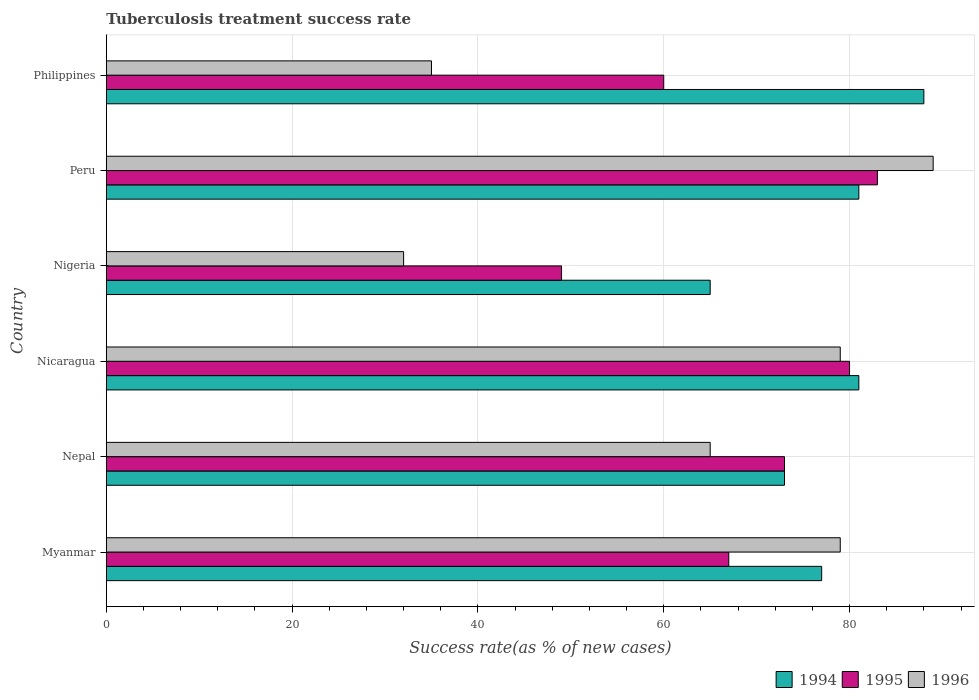Are the number of bars per tick equal to the number of legend labels?
Your answer should be very brief. Yes. How many bars are there on the 3rd tick from the top?
Your response must be concise. 3. How many bars are there on the 3rd tick from the bottom?
Give a very brief answer. 3. What is the label of the 1st group of bars from the top?
Your response must be concise. Philippines. In how many cases, is the number of bars for a given country not equal to the number of legend labels?
Make the answer very short. 0. What is the tuberculosis treatment success rate in 1995 in Philippines?
Provide a short and direct response. 60. Across all countries, what is the minimum tuberculosis treatment success rate in 1994?
Offer a very short reply. 65. In which country was the tuberculosis treatment success rate in 1996 maximum?
Offer a very short reply. Peru. In which country was the tuberculosis treatment success rate in 1995 minimum?
Provide a short and direct response. Nigeria. What is the total tuberculosis treatment success rate in 1994 in the graph?
Your answer should be compact. 465. What is the difference between the tuberculosis treatment success rate in 1994 in Myanmar and the tuberculosis treatment success rate in 1995 in Nigeria?
Your response must be concise. 28. What is the average tuberculosis treatment success rate in 1995 per country?
Provide a short and direct response. 68.67. What is the difference between the tuberculosis treatment success rate in 1996 and tuberculosis treatment success rate in 1995 in Peru?
Provide a succinct answer. 6. What is the ratio of the tuberculosis treatment success rate in 1995 in Myanmar to that in Philippines?
Ensure brevity in your answer.  1.12. In how many countries, is the tuberculosis treatment success rate in 1996 greater than the average tuberculosis treatment success rate in 1996 taken over all countries?
Ensure brevity in your answer.  4. What does the 3rd bar from the top in Nepal represents?
Provide a short and direct response. 1994. How many bars are there?
Provide a succinct answer. 18. Are all the bars in the graph horizontal?
Your answer should be compact. Yes. Does the graph contain any zero values?
Your response must be concise. No. How many legend labels are there?
Provide a short and direct response. 3. How are the legend labels stacked?
Your answer should be very brief. Horizontal. What is the title of the graph?
Your answer should be very brief. Tuberculosis treatment success rate. What is the label or title of the X-axis?
Your answer should be compact. Success rate(as % of new cases). What is the label or title of the Y-axis?
Ensure brevity in your answer.  Country. What is the Success rate(as % of new cases) of 1996 in Myanmar?
Make the answer very short. 79. What is the Success rate(as % of new cases) in 1995 in Nepal?
Give a very brief answer. 73. What is the Success rate(as % of new cases) in 1995 in Nicaragua?
Keep it short and to the point. 80. What is the Success rate(as % of new cases) of 1996 in Nicaragua?
Provide a succinct answer. 79. What is the Success rate(as % of new cases) of 1994 in Nigeria?
Ensure brevity in your answer.  65. What is the Success rate(as % of new cases) in 1995 in Nigeria?
Ensure brevity in your answer.  49. What is the Success rate(as % of new cases) in 1996 in Nigeria?
Provide a short and direct response. 32. What is the Success rate(as % of new cases) of 1995 in Peru?
Give a very brief answer. 83. What is the Success rate(as % of new cases) in 1996 in Peru?
Provide a succinct answer. 89. What is the Success rate(as % of new cases) of 1994 in Philippines?
Keep it short and to the point. 88. What is the Success rate(as % of new cases) of 1996 in Philippines?
Your answer should be compact. 35. Across all countries, what is the maximum Success rate(as % of new cases) of 1996?
Provide a succinct answer. 89. What is the total Success rate(as % of new cases) of 1994 in the graph?
Give a very brief answer. 465. What is the total Success rate(as % of new cases) in 1995 in the graph?
Offer a very short reply. 412. What is the total Success rate(as % of new cases) in 1996 in the graph?
Give a very brief answer. 379. What is the difference between the Success rate(as % of new cases) of 1994 in Myanmar and that in Nepal?
Your answer should be very brief. 4. What is the difference between the Success rate(as % of new cases) of 1996 in Myanmar and that in Nigeria?
Your answer should be very brief. 47. What is the difference between the Success rate(as % of new cases) of 1996 in Myanmar and that in Peru?
Offer a very short reply. -10. What is the difference between the Success rate(as % of new cases) of 1994 in Myanmar and that in Philippines?
Ensure brevity in your answer.  -11. What is the difference between the Success rate(as % of new cases) in 1995 in Myanmar and that in Philippines?
Offer a very short reply. 7. What is the difference between the Success rate(as % of new cases) in 1996 in Myanmar and that in Philippines?
Keep it short and to the point. 44. What is the difference between the Success rate(as % of new cases) of 1995 in Nepal and that in Nigeria?
Keep it short and to the point. 24. What is the difference between the Success rate(as % of new cases) in 1996 in Nepal and that in Peru?
Your answer should be very brief. -24. What is the difference between the Success rate(as % of new cases) in 1995 in Nepal and that in Philippines?
Offer a very short reply. 13. What is the difference between the Success rate(as % of new cases) of 1996 in Nepal and that in Philippines?
Your response must be concise. 30. What is the difference between the Success rate(as % of new cases) of 1995 in Nicaragua and that in Peru?
Offer a terse response. -3. What is the difference between the Success rate(as % of new cases) of 1994 in Nicaragua and that in Philippines?
Offer a terse response. -7. What is the difference between the Success rate(as % of new cases) in 1995 in Nicaragua and that in Philippines?
Provide a succinct answer. 20. What is the difference between the Success rate(as % of new cases) of 1996 in Nicaragua and that in Philippines?
Offer a very short reply. 44. What is the difference between the Success rate(as % of new cases) of 1994 in Nigeria and that in Peru?
Your answer should be compact. -16. What is the difference between the Success rate(as % of new cases) of 1995 in Nigeria and that in Peru?
Ensure brevity in your answer.  -34. What is the difference between the Success rate(as % of new cases) of 1996 in Nigeria and that in Peru?
Your response must be concise. -57. What is the difference between the Success rate(as % of new cases) of 1994 in Nigeria and that in Philippines?
Keep it short and to the point. -23. What is the difference between the Success rate(as % of new cases) in 1995 in Nigeria and that in Philippines?
Provide a succinct answer. -11. What is the difference between the Success rate(as % of new cases) in 1996 in Nigeria and that in Philippines?
Offer a terse response. -3. What is the difference between the Success rate(as % of new cases) of 1995 in Myanmar and the Success rate(as % of new cases) of 1996 in Nepal?
Keep it short and to the point. 2. What is the difference between the Success rate(as % of new cases) of 1995 in Myanmar and the Success rate(as % of new cases) of 1996 in Nicaragua?
Offer a terse response. -12. What is the difference between the Success rate(as % of new cases) of 1995 in Myanmar and the Success rate(as % of new cases) of 1996 in Nigeria?
Give a very brief answer. 35. What is the difference between the Success rate(as % of new cases) of 1994 in Myanmar and the Success rate(as % of new cases) of 1995 in Peru?
Provide a succinct answer. -6. What is the difference between the Success rate(as % of new cases) of 1994 in Myanmar and the Success rate(as % of new cases) of 1996 in Peru?
Provide a short and direct response. -12. What is the difference between the Success rate(as % of new cases) of 1994 in Myanmar and the Success rate(as % of new cases) of 1996 in Philippines?
Provide a short and direct response. 42. What is the difference between the Success rate(as % of new cases) in 1995 in Myanmar and the Success rate(as % of new cases) in 1996 in Philippines?
Your answer should be very brief. 32. What is the difference between the Success rate(as % of new cases) of 1994 in Nepal and the Success rate(as % of new cases) of 1996 in Nicaragua?
Provide a short and direct response. -6. What is the difference between the Success rate(as % of new cases) in 1994 in Nepal and the Success rate(as % of new cases) in 1995 in Nigeria?
Ensure brevity in your answer.  24. What is the difference between the Success rate(as % of new cases) in 1994 in Nepal and the Success rate(as % of new cases) in 1995 in Peru?
Keep it short and to the point. -10. What is the difference between the Success rate(as % of new cases) in 1994 in Nepal and the Success rate(as % of new cases) in 1995 in Philippines?
Offer a very short reply. 13. What is the difference between the Success rate(as % of new cases) in 1994 in Nicaragua and the Success rate(as % of new cases) in 1995 in Peru?
Your answer should be very brief. -2. What is the difference between the Success rate(as % of new cases) of 1995 in Nicaragua and the Success rate(as % of new cases) of 1996 in Peru?
Offer a terse response. -9. What is the difference between the Success rate(as % of new cases) in 1995 in Nicaragua and the Success rate(as % of new cases) in 1996 in Philippines?
Your answer should be compact. 45. What is the difference between the Success rate(as % of new cases) in 1995 in Nigeria and the Success rate(as % of new cases) in 1996 in Peru?
Make the answer very short. -40. What is the difference between the Success rate(as % of new cases) of 1994 in Nigeria and the Success rate(as % of new cases) of 1995 in Philippines?
Offer a very short reply. 5. What is the difference between the Success rate(as % of new cases) of 1994 in Nigeria and the Success rate(as % of new cases) of 1996 in Philippines?
Make the answer very short. 30. What is the difference between the Success rate(as % of new cases) in 1994 in Peru and the Success rate(as % of new cases) in 1996 in Philippines?
Give a very brief answer. 46. What is the difference between the Success rate(as % of new cases) of 1995 in Peru and the Success rate(as % of new cases) of 1996 in Philippines?
Provide a short and direct response. 48. What is the average Success rate(as % of new cases) of 1994 per country?
Give a very brief answer. 77.5. What is the average Success rate(as % of new cases) in 1995 per country?
Your answer should be very brief. 68.67. What is the average Success rate(as % of new cases) of 1996 per country?
Provide a short and direct response. 63.17. What is the difference between the Success rate(as % of new cases) of 1994 and Success rate(as % of new cases) of 1996 in Myanmar?
Offer a very short reply. -2. What is the difference between the Success rate(as % of new cases) of 1995 and Success rate(as % of new cases) of 1996 in Myanmar?
Offer a terse response. -12. What is the difference between the Success rate(as % of new cases) of 1994 and Success rate(as % of new cases) of 1995 in Nepal?
Provide a short and direct response. 0. What is the difference between the Success rate(as % of new cases) of 1994 and Success rate(as % of new cases) of 1995 in Nicaragua?
Your response must be concise. 1. What is the difference between the Success rate(as % of new cases) of 1994 and Success rate(as % of new cases) of 1996 in Nicaragua?
Keep it short and to the point. 2. What is the difference between the Success rate(as % of new cases) in 1994 and Success rate(as % of new cases) in 1996 in Nigeria?
Provide a succinct answer. 33. What is the difference between the Success rate(as % of new cases) in 1995 and Success rate(as % of new cases) in 1996 in Nigeria?
Provide a succinct answer. 17. What is the difference between the Success rate(as % of new cases) of 1994 and Success rate(as % of new cases) of 1995 in Peru?
Give a very brief answer. -2. What is the difference between the Success rate(as % of new cases) in 1994 and Success rate(as % of new cases) in 1996 in Peru?
Your answer should be compact. -8. What is the difference between the Success rate(as % of new cases) of 1994 and Success rate(as % of new cases) of 1995 in Philippines?
Your answer should be very brief. 28. What is the difference between the Success rate(as % of new cases) of 1994 and Success rate(as % of new cases) of 1996 in Philippines?
Your answer should be very brief. 53. What is the difference between the Success rate(as % of new cases) of 1995 and Success rate(as % of new cases) of 1996 in Philippines?
Offer a terse response. 25. What is the ratio of the Success rate(as % of new cases) in 1994 in Myanmar to that in Nepal?
Provide a short and direct response. 1.05. What is the ratio of the Success rate(as % of new cases) in 1995 in Myanmar to that in Nepal?
Offer a terse response. 0.92. What is the ratio of the Success rate(as % of new cases) in 1996 in Myanmar to that in Nepal?
Your answer should be compact. 1.22. What is the ratio of the Success rate(as % of new cases) in 1994 in Myanmar to that in Nicaragua?
Offer a very short reply. 0.95. What is the ratio of the Success rate(as % of new cases) in 1995 in Myanmar to that in Nicaragua?
Your answer should be compact. 0.84. What is the ratio of the Success rate(as % of new cases) of 1996 in Myanmar to that in Nicaragua?
Offer a very short reply. 1. What is the ratio of the Success rate(as % of new cases) in 1994 in Myanmar to that in Nigeria?
Make the answer very short. 1.18. What is the ratio of the Success rate(as % of new cases) in 1995 in Myanmar to that in Nigeria?
Keep it short and to the point. 1.37. What is the ratio of the Success rate(as % of new cases) of 1996 in Myanmar to that in Nigeria?
Offer a terse response. 2.47. What is the ratio of the Success rate(as % of new cases) in 1994 in Myanmar to that in Peru?
Ensure brevity in your answer.  0.95. What is the ratio of the Success rate(as % of new cases) of 1995 in Myanmar to that in Peru?
Make the answer very short. 0.81. What is the ratio of the Success rate(as % of new cases) in 1996 in Myanmar to that in Peru?
Your answer should be compact. 0.89. What is the ratio of the Success rate(as % of new cases) of 1995 in Myanmar to that in Philippines?
Provide a succinct answer. 1.12. What is the ratio of the Success rate(as % of new cases) in 1996 in Myanmar to that in Philippines?
Offer a very short reply. 2.26. What is the ratio of the Success rate(as % of new cases) in 1994 in Nepal to that in Nicaragua?
Make the answer very short. 0.9. What is the ratio of the Success rate(as % of new cases) of 1995 in Nepal to that in Nicaragua?
Provide a short and direct response. 0.91. What is the ratio of the Success rate(as % of new cases) in 1996 in Nepal to that in Nicaragua?
Your response must be concise. 0.82. What is the ratio of the Success rate(as % of new cases) in 1994 in Nepal to that in Nigeria?
Offer a very short reply. 1.12. What is the ratio of the Success rate(as % of new cases) of 1995 in Nepal to that in Nigeria?
Offer a very short reply. 1.49. What is the ratio of the Success rate(as % of new cases) of 1996 in Nepal to that in Nigeria?
Your answer should be compact. 2.03. What is the ratio of the Success rate(as % of new cases) in 1994 in Nepal to that in Peru?
Offer a terse response. 0.9. What is the ratio of the Success rate(as % of new cases) in 1995 in Nepal to that in Peru?
Your answer should be very brief. 0.88. What is the ratio of the Success rate(as % of new cases) of 1996 in Nepal to that in Peru?
Ensure brevity in your answer.  0.73. What is the ratio of the Success rate(as % of new cases) of 1994 in Nepal to that in Philippines?
Your response must be concise. 0.83. What is the ratio of the Success rate(as % of new cases) of 1995 in Nepal to that in Philippines?
Ensure brevity in your answer.  1.22. What is the ratio of the Success rate(as % of new cases) in 1996 in Nepal to that in Philippines?
Provide a short and direct response. 1.86. What is the ratio of the Success rate(as % of new cases) of 1994 in Nicaragua to that in Nigeria?
Your answer should be very brief. 1.25. What is the ratio of the Success rate(as % of new cases) in 1995 in Nicaragua to that in Nigeria?
Offer a very short reply. 1.63. What is the ratio of the Success rate(as % of new cases) in 1996 in Nicaragua to that in Nigeria?
Provide a short and direct response. 2.47. What is the ratio of the Success rate(as % of new cases) in 1995 in Nicaragua to that in Peru?
Give a very brief answer. 0.96. What is the ratio of the Success rate(as % of new cases) in 1996 in Nicaragua to that in Peru?
Offer a terse response. 0.89. What is the ratio of the Success rate(as % of new cases) of 1994 in Nicaragua to that in Philippines?
Provide a succinct answer. 0.92. What is the ratio of the Success rate(as % of new cases) in 1995 in Nicaragua to that in Philippines?
Give a very brief answer. 1.33. What is the ratio of the Success rate(as % of new cases) of 1996 in Nicaragua to that in Philippines?
Your answer should be compact. 2.26. What is the ratio of the Success rate(as % of new cases) in 1994 in Nigeria to that in Peru?
Your answer should be compact. 0.8. What is the ratio of the Success rate(as % of new cases) of 1995 in Nigeria to that in Peru?
Keep it short and to the point. 0.59. What is the ratio of the Success rate(as % of new cases) of 1996 in Nigeria to that in Peru?
Offer a terse response. 0.36. What is the ratio of the Success rate(as % of new cases) of 1994 in Nigeria to that in Philippines?
Keep it short and to the point. 0.74. What is the ratio of the Success rate(as % of new cases) of 1995 in Nigeria to that in Philippines?
Offer a terse response. 0.82. What is the ratio of the Success rate(as % of new cases) in 1996 in Nigeria to that in Philippines?
Provide a succinct answer. 0.91. What is the ratio of the Success rate(as % of new cases) of 1994 in Peru to that in Philippines?
Keep it short and to the point. 0.92. What is the ratio of the Success rate(as % of new cases) of 1995 in Peru to that in Philippines?
Provide a succinct answer. 1.38. What is the ratio of the Success rate(as % of new cases) of 1996 in Peru to that in Philippines?
Keep it short and to the point. 2.54. What is the difference between the highest and the second highest Success rate(as % of new cases) in 1995?
Offer a terse response. 3. 